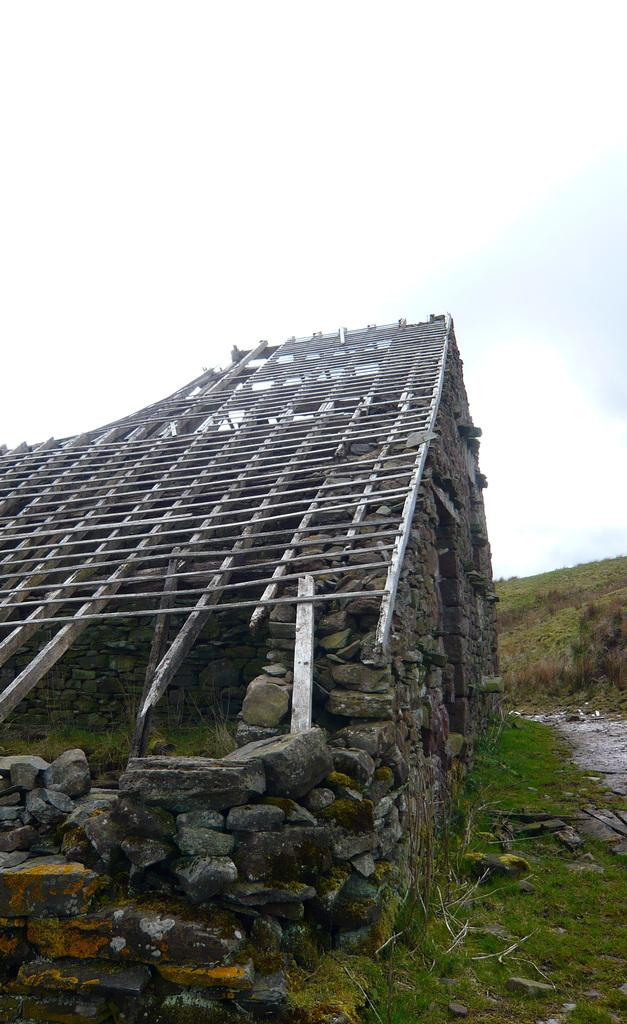What type of structure is in the image? There is a wooden structure in the image. How is the wooden structure positioned in the image? The wooden structure is on rocks. What type of vegetation is present at the bottom of the image? There is grass on the surface at the bottom of the image. What can be seen in the background of the image? The sky is visible in the background of the image. Can you see a friend holding a tray and a brush in the image? There is no friend, tray, or brush present in the image. 